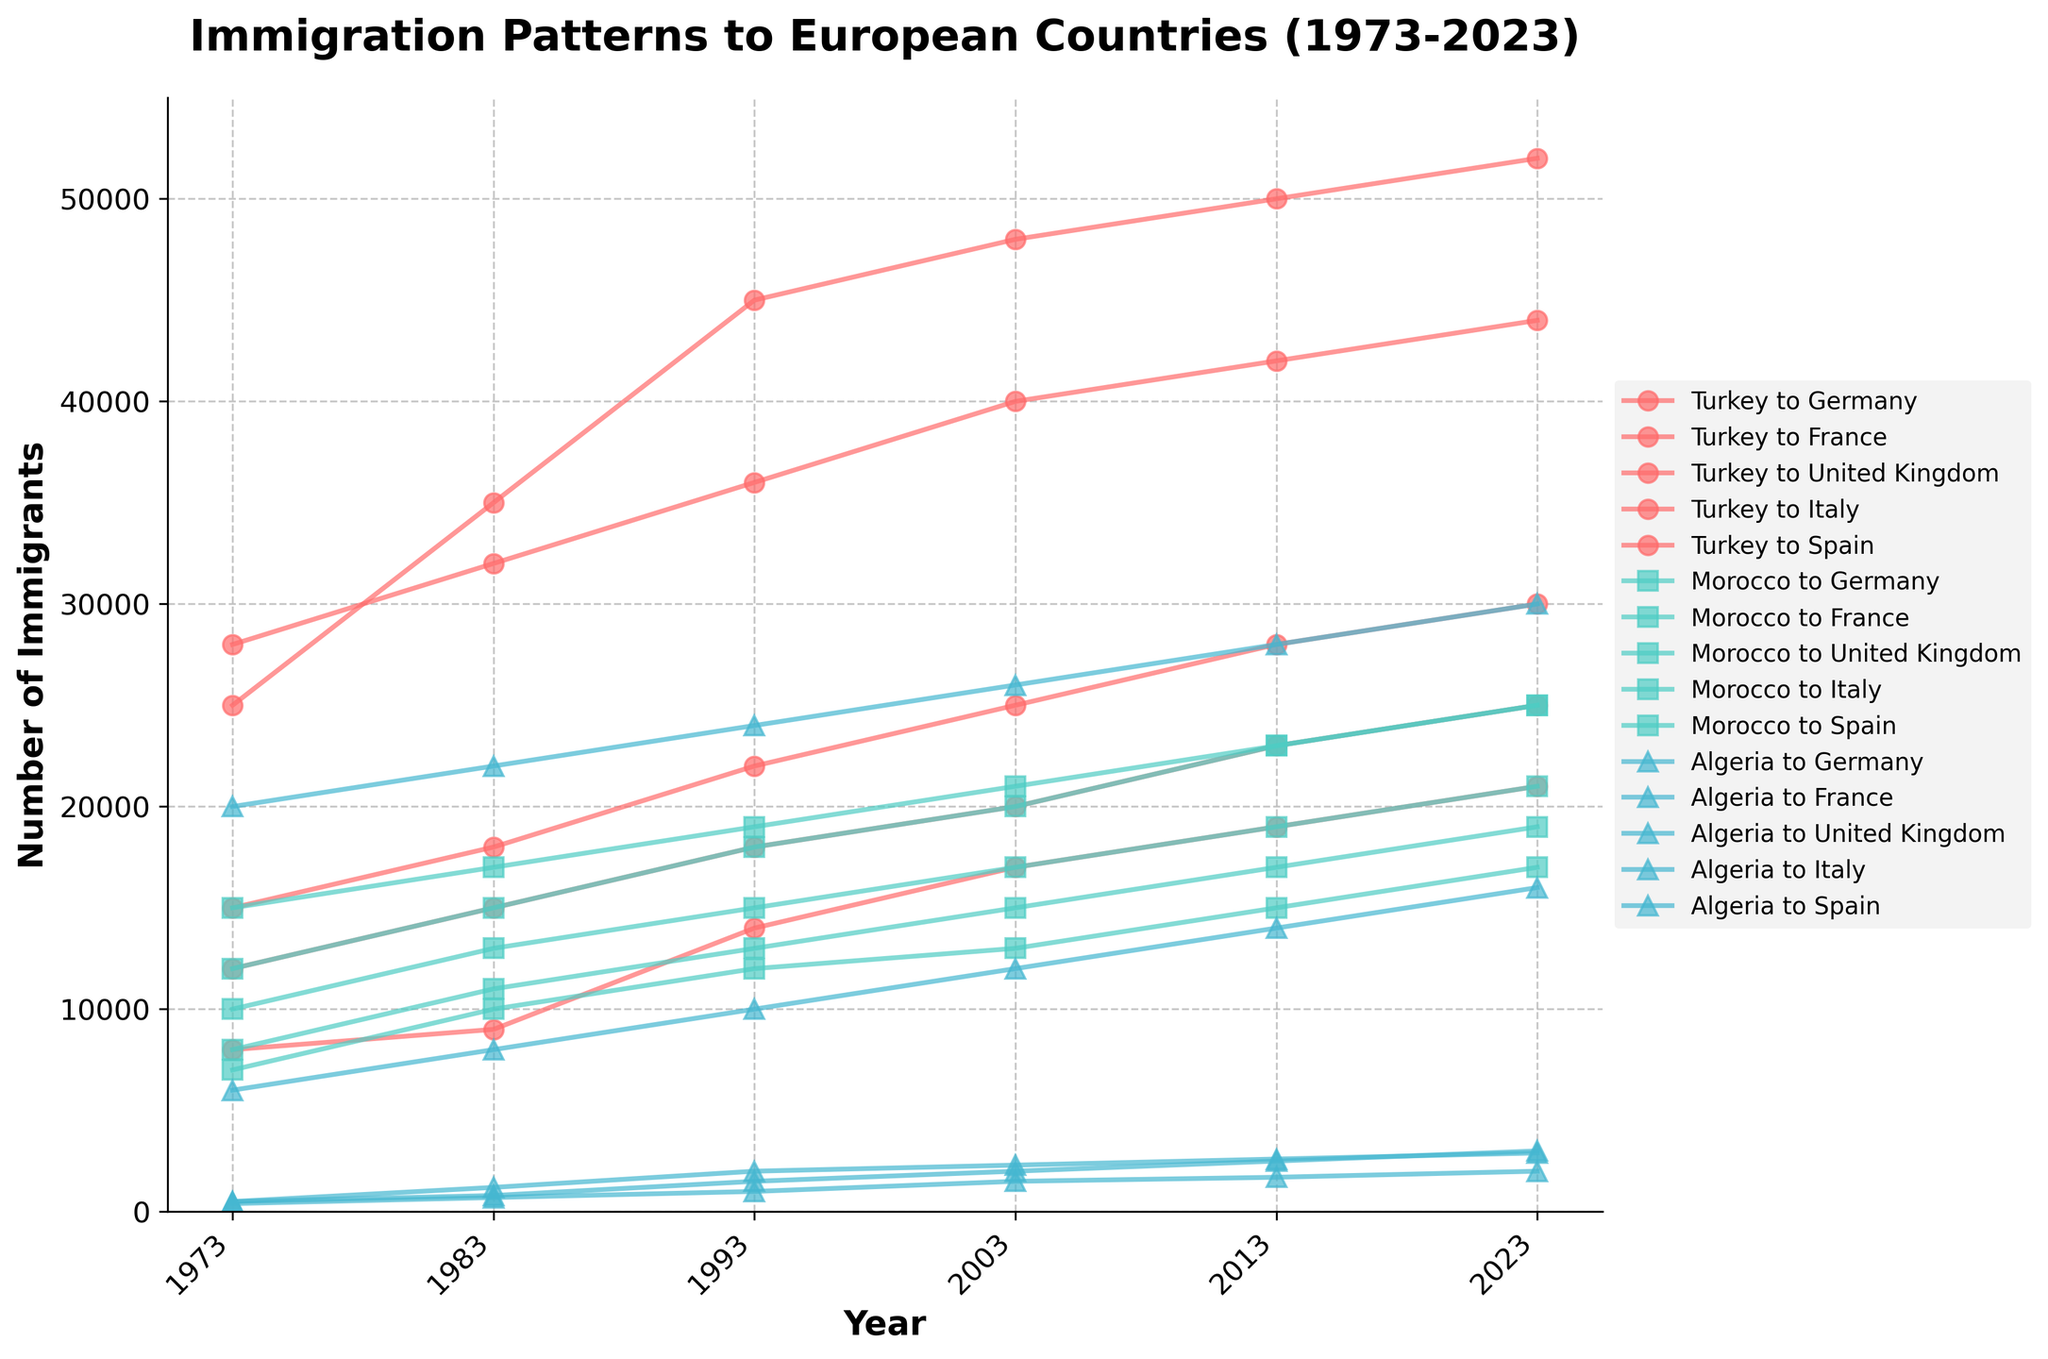What countries are plotted in the figure as origins of immigrants? The figure shows immigration patterns from three countries. Each country has a unique color and marker symbol in the plot, identifying them from origin to destination.
Answer: Turkey, Morocco, Algeria What is the title of the figure? The title is placed at the top of the figure in a larger and bold font style, providing an overview of what the figure is about.
Answer: Immigration Patterns to European Countries (1973-2023) Which country received the most immigrants from Turkey in 2023? The figure plots the number of immigrants from Turkey to each destination country using different colors and markers. You can reference the highest plotted point for Turkey in 2023.
Answer: Germany What patterns can you observe for Morocco's immigration to France from 1973 to 2023? By examining the data points connected by lines, you can observe the trend over time for Morocco's immigration to France. Look at the increasing or decreasing pattern.
Answer: Increasing trend What's the total number of immigrants from Algeria to the United Kingdom in 2023? Find the plotted data point for Algeria to the United Kingdom in 2023. The y-axis value corresponding to this point gives the number of immigrants.
Answer: 16000 Which country of origin has shown the most significant increase in immigration to Italy over the last 50 years? Compare the data points for each country of origin that show immigration to Italy, looking at the increases from 1973 to 2023. Determine which country has the largest difference between the starting and ending points.
Answer: Turkey What is the average number of Moroccan immigrants to Spain over the 50 years? Add all the y-axis values corresponding to Moroccan immigration to Spain from 1973 to 2023, then divide by the total number of years (which is seven).
Answer: (7000 + 10000 + 12000 + 13000 + 15000 + 17000 + 19000) / 7 ≈ 13357 Did any country of origin show a decline in immigration to Germany at any point in the last 50 years? Evaluate the plotted lines for each country of origin to Germany, checking if there is any point-to-point decrease over the years.
Answer: No Compare the number of Turkish immigrants to France and the United Kingdom in 2003. Which is higher? Reference the plot points for Turkish immigrants to both France and the United Kingdom in 2003 and compare the values.
Answer: France Which country has consistently shown a higher number of immigrants from Algeria since 1973, Germany or France? Track the plotted points for Algerian immigrants to both Germany and France from 1973 to 2023 and see which line consistently appears higher on the y-axis.
Answer: France 